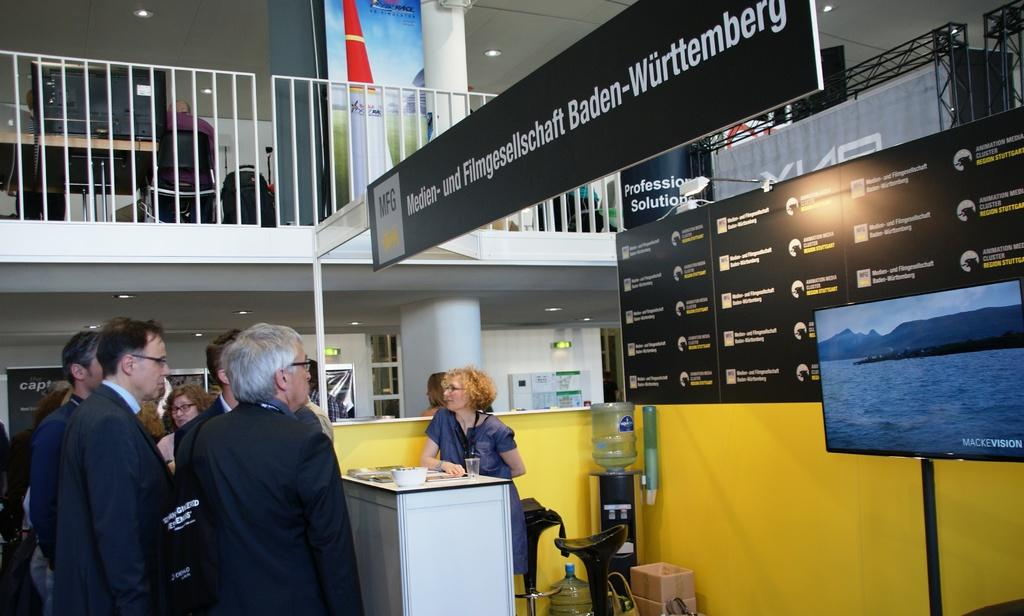<image>
Offer a succinct explanation of the picture presented. The men are crowding around a booth for the Fulmgesellscaft from Baden-Wurttemberg run my a middle aged woman with blonde curly hair. 